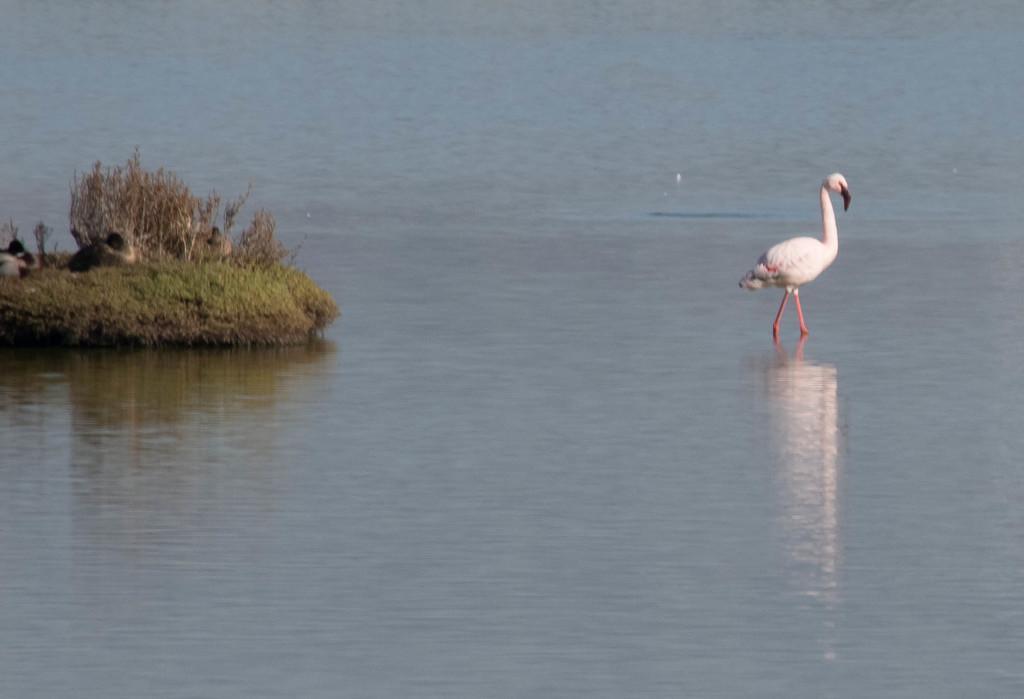Describe this image in one or two sentences. In this image we can see flamingo in the water. On the left side there's grass on the ground. Also there are ducks. 